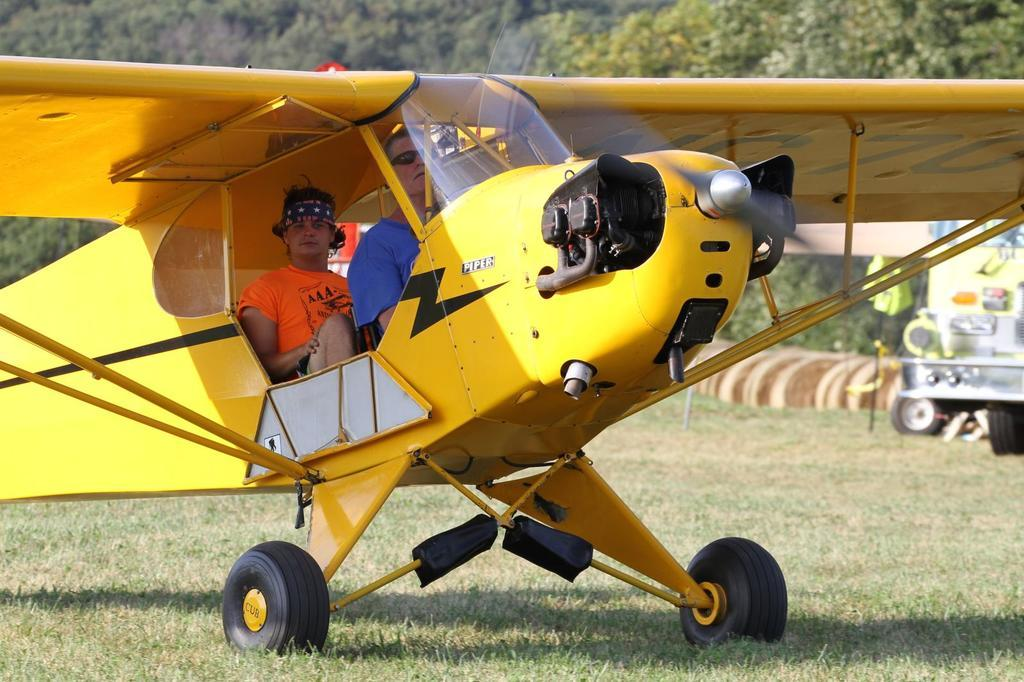What is the main setting of the image? There is an open grass ground in the image. What can be seen on the grass ground? There is a yellow-colored aircraft on the grass ground. Who is present in the image? There are two men sitting in the image. What can be seen in the distance in the image? There are trees visible in the background of the image. What type of roof can be seen on the aircraft in the image? There is no roof visible on the aircraft in the image, as it is an open-air aircraft. What committee is responsible for organizing the competition in the image? There is no competition or committee present in the image; it features an aircraft on a grass ground with two men sitting. 